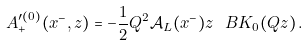Convert formula to latex. <formula><loc_0><loc_0><loc_500><loc_500>A ^ { \prime ( 0 ) } _ { + } ( x ^ { - } , z ) = - \frac { 1 } { 2 } Q ^ { 2 } \mathcal { A } _ { L } ( x ^ { - } ) z \ B K _ { 0 } ( Q z ) \, .</formula> 